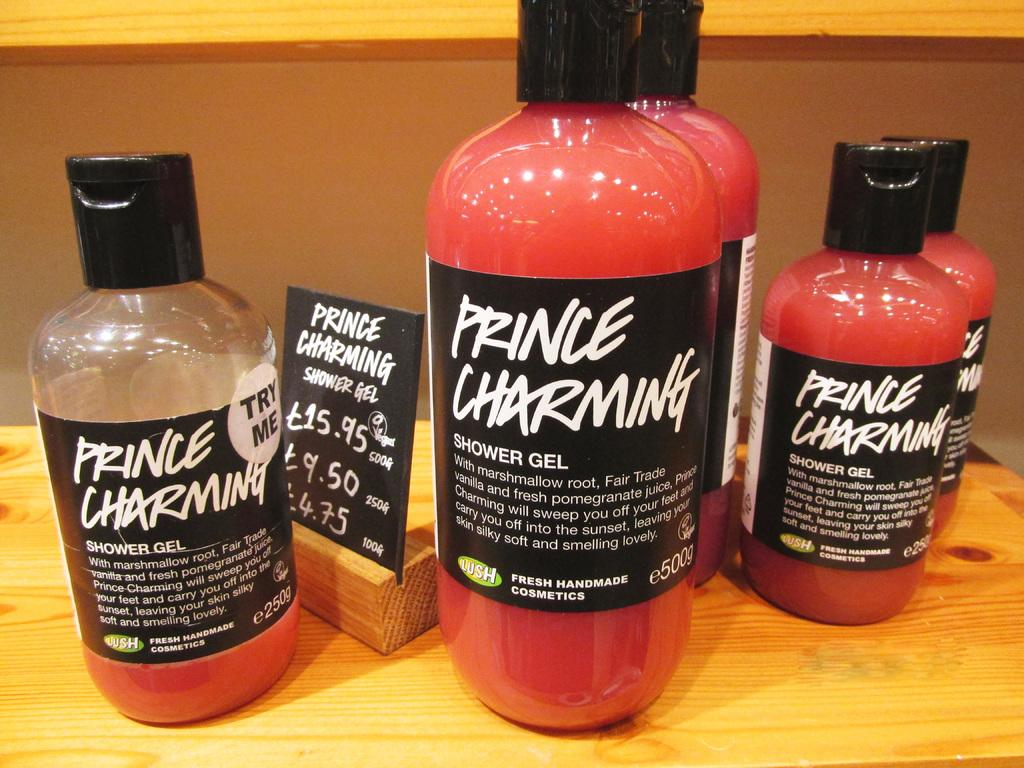<image>
Write a terse but informative summary of the picture. A pinkish red shower gel has the brand name Prince Charming. 